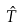<formula> <loc_0><loc_0><loc_500><loc_500>\hat { T }</formula> 